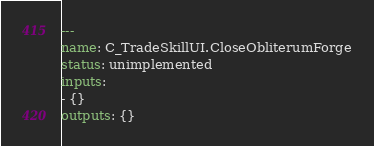<code> <loc_0><loc_0><loc_500><loc_500><_YAML_>---
name: C_TradeSkillUI.CloseObliterumForge
status: unimplemented
inputs:
- {}
outputs: {}
</code> 